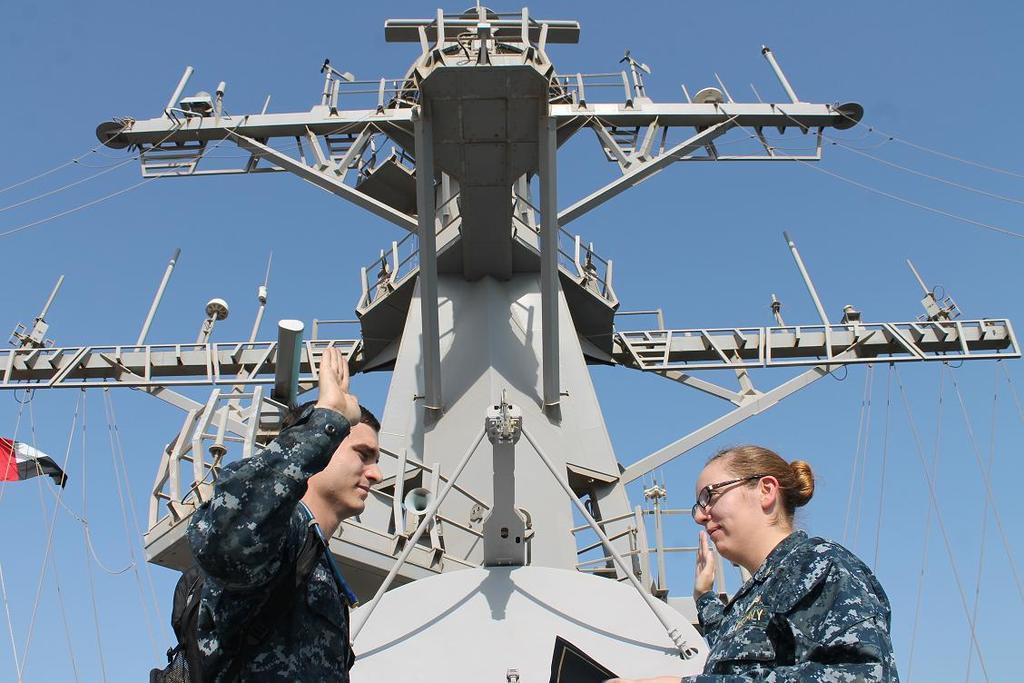How would you summarize this image in a sentence or two? This picture shows a man and a woman standing we see a tower and a flag. Women wore spectacles on her face and we see a blue sky. 